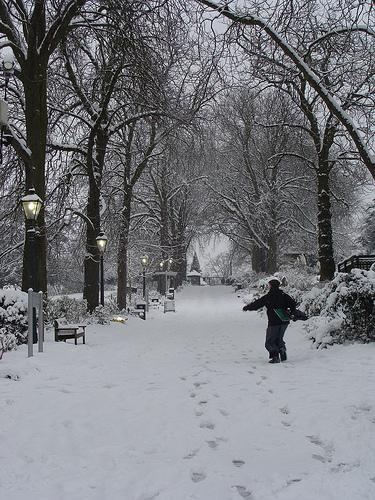Create a short and vivid description of the picture, focusing on the overall ambiance and weather. A serene winter wonderland unfolds in the snow-covered city, with a snowboarder adding a touch of adventure. Write a short sentence about the primary human character in the photograph and what he's holding in his arms. A man is walking in the snow, carrying a green snowboard in his arms. Mention a notable piece of furniture in the image and its condition. A bench sits outside, covered in a thick layer of snow. Give a brief description of one of the street lamps in the image. A black lamp post with a lit light stands out in the snowy scene. Craft a brief narrative about the picture, including the scenery and a person. In this snowy city scene, a man holds tightly onto his green snowboard, ready to conquer the wintery day. Provide a concise summary of the picture, emphasizing the atmosphere and one particular human element. In a snow-covered city scene, a man with a green snowboard navigates through the wintery landscape. Narrate an overview of the scene captured in the image with a focus on the noticeable objects. A snowy landscape with multiple lamp posts, a man holding a snowboard, a snow-covered bench, tracks in the snow, and trees. Describe what seems to be the primary activity happening in the photograph from a human perspective. A man, heavily dressed, is carrying his snowboard while walking through the snow. Mention a particular aspect of the image related to weather and how it has affected the objects. Heavy snow has covered the landscape, leaving trees, bushes, and a bench blanketed in a thick layer of white. Highlight one element of nature that is visible in the image and mention its current state. A row of snow-covered bushes lines the landscape, beautifully showcasing winter's impact. 